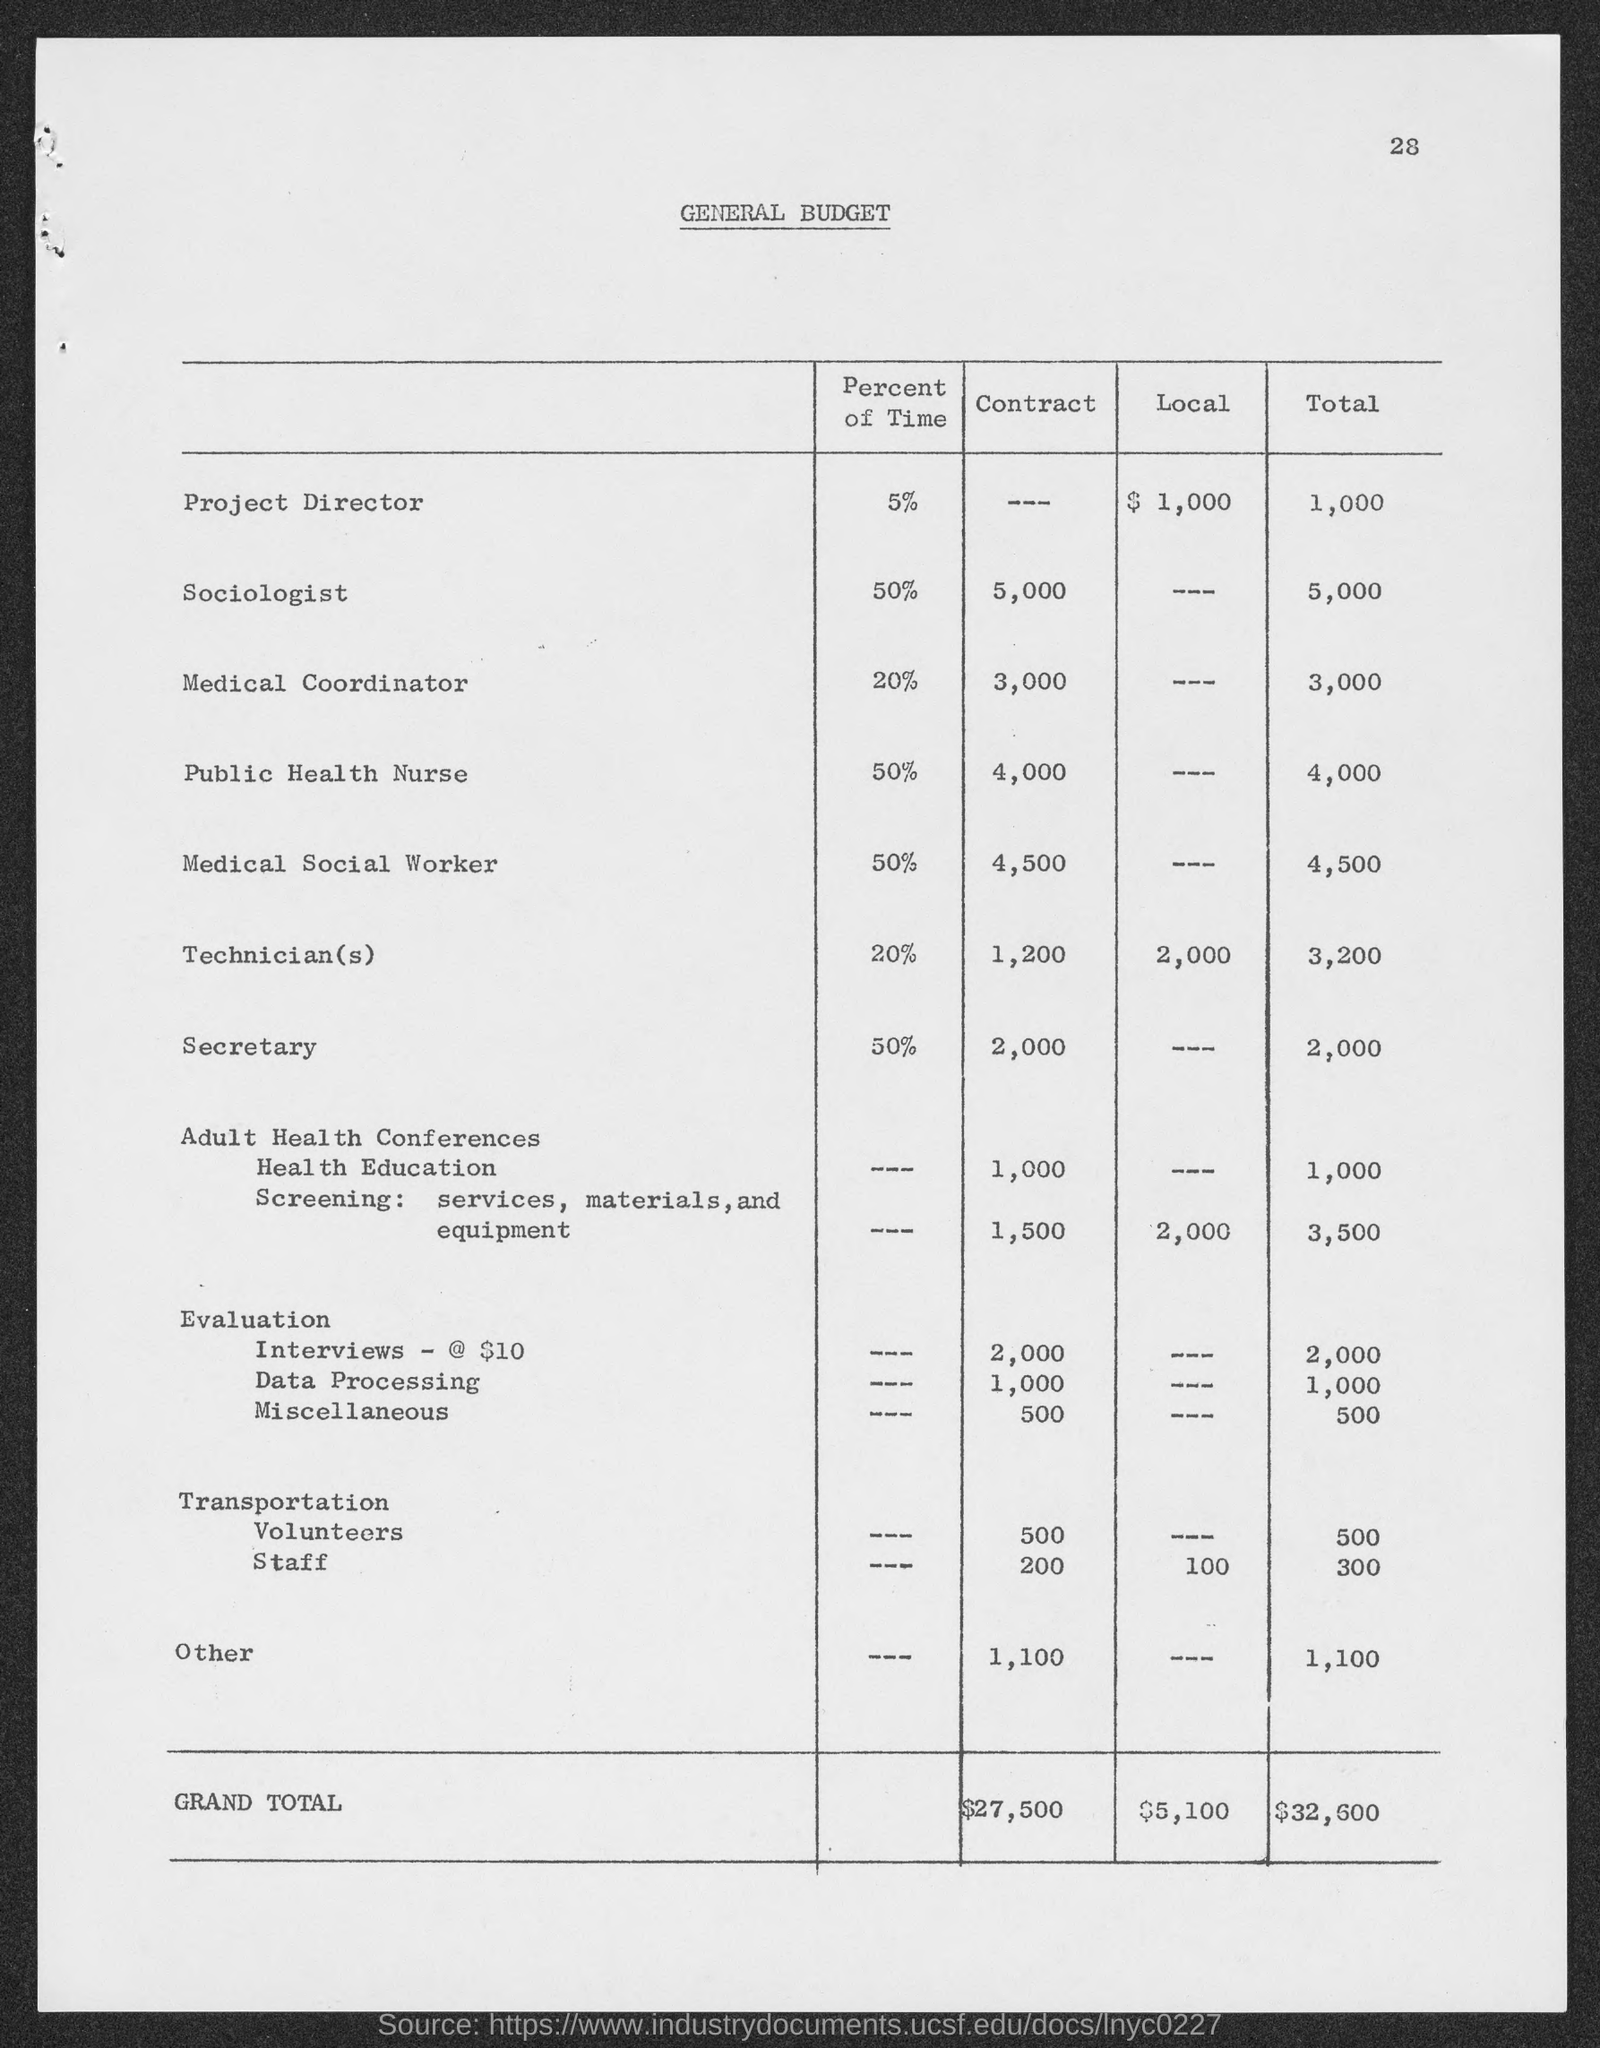What is the total budget listed for Adult Health Conferences, Health Education, and Screening combined? The total budget for Adult Health Conferences is $1,000, for Health Education it's $1,500, and for Screening, which includes services, materials, and equipment, it's $3,500. Combined, the total budget for these items is $6,000. 